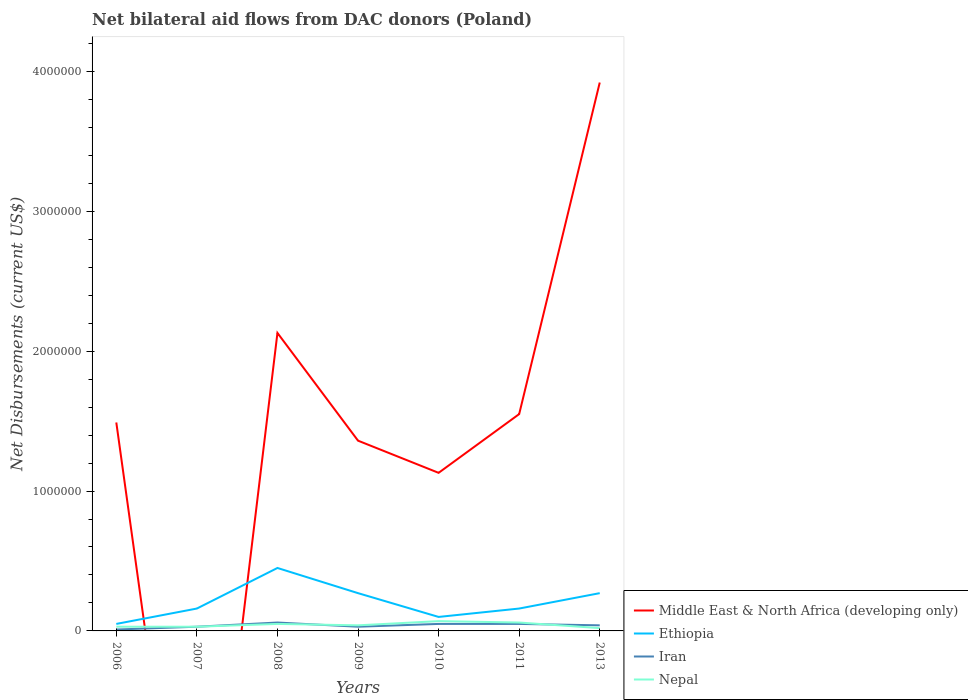Is the number of lines equal to the number of legend labels?
Offer a terse response. No. Across all years, what is the maximum net bilateral aid flows in Ethiopia?
Keep it short and to the point. 5.00e+04. What is the difference between the highest and the second highest net bilateral aid flows in Ethiopia?
Provide a short and direct response. 4.00e+05. What is the difference between the highest and the lowest net bilateral aid flows in Nepal?
Offer a very short reply. 3. Are the values on the major ticks of Y-axis written in scientific E-notation?
Make the answer very short. No. How many legend labels are there?
Offer a terse response. 4. How are the legend labels stacked?
Provide a succinct answer. Vertical. What is the title of the graph?
Ensure brevity in your answer.  Net bilateral aid flows from DAC donors (Poland). Does "Thailand" appear as one of the legend labels in the graph?
Make the answer very short. No. What is the label or title of the X-axis?
Keep it short and to the point. Years. What is the label or title of the Y-axis?
Ensure brevity in your answer.  Net Disbursements (current US$). What is the Net Disbursements (current US$) of Middle East & North Africa (developing only) in 2006?
Offer a terse response. 1.49e+06. What is the Net Disbursements (current US$) of Nepal in 2007?
Provide a succinct answer. 3.00e+04. What is the Net Disbursements (current US$) in Middle East & North Africa (developing only) in 2008?
Your response must be concise. 2.13e+06. What is the Net Disbursements (current US$) of Iran in 2008?
Provide a succinct answer. 6.00e+04. What is the Net Disbursements (current US$) of Middle East & North Africa (developing only) in 2009?
Make the answer very short. 1.36e+06. What is the Net Disbursements (current US$) of Ethiopia in 2009?
Your response must be concise. 2.70e+05. What is the Net Disbursements (current US$) in Iran in 2009?
Your answer should be compact. 3.00e+04. What is the Net Disbursements (current US$) of Middle East & North Africa (developing only) in 2010?
Provide a succinct answer. 1.13e+06. What is the Net Disbursements (current US$) in Ethiopia in 2010?
Ensure brevity in your answer.  1.00e+05. What is the Net Disbursements (current US$) of Nepal in 2010?
Your response must be concise. 7.00e+04. What is the Net Disbursements (current US$) in Middle East & North Africa (developing only) in 2011?
Give a very brief answer. 1.55e+06. What is the Net Disbursements (current US$) of Ethiopia in 2011?
Ensure brevity in your answer.  1.60e+05. What is the Net Disbursements (current US$) of Middle East & North Africa (developing only) in 2013?
Your response must be concise. 3.92e+06. What is the Net Disbursements (current US$) of Ethiopia in 2013?
Your answer should be compact. 2.70e+05. What is the Net Disbursements (current US$) of Iran in 2013?
Give a very brief answer. 4.00e+04. What is the Net Disbursements (current US$) in Nepal in 2013?
Offer a very short reply. 2.00e+04. Across all years, what is the maximum Net Disbursements (current US$) in Middle East & North Africa (developing only)?
Your response must be concise. 3.92e+06. Across all years, what is the maximum Net Disbursements (current US$) in Ethiopia?
Make the answer very short. 4.50e+05. Across all years, what is the maximum Net Disbursements (current US$) in Iran?
Provide a short and direct response. 6.00e+04. Across all years, what is the maximum Net Disbursements (current US$) in Nepal?
Offer a terse response. 7.00e+04. Across all years, what is the minimum Net Disbursements (current US$) in Nepal?
Your answer should be compact. 2.00e+04. What is the total Net Disbursements (current US$) of Middle East & North Africa (developing only) in the graph?
Provide a short and direct response. 1.16e+07. What is the total Net Disbursements (current US$) in Ethiopia in the graph?
Provide a short and direct response. 1.46e+06. What is the total Net Disbursements (current US$) in Iran in the graph?
Your answer should be very brief. 2.70e+05. What is the total Net Disbursements (current US$) of Nepal in the graph?
Your answer should be compact. 3.00e+05. What is the difference between the Net Disbursements (current US$) in Ethiopia in 2006 and that in 2007?
Keep it short and to the point. -1.10e+05. What is the difference between the Net Disbursements (current US$) in Iran in 2006 and that in 2007?
Your answer should be compact. -2.00e+04. What is the difference between the Net Disbursements (current US$) of Middle East & North Africa (developing only) in 2006 and that in 2008?
Offer a terse response. -6.40e+05. What is the difference between the Net Disbursements (current US$) of Ethiopia in 2006 and that in 2008?
Offer a terse response. -4.00e+05. What is the difference between the Net Disbursements (current US$) of Nepal in 2006 and that in 2008?
Give a very brief answer. -2.00e+04. What is the difference between the Net Disbursements (current US$) of Middle East & North Africa (developing only) in 2006 and that in 2009?
Offer a very short reply. 1.30e+05. What is the difference between the Net Disbursements (current US$) of Ethiopia in 2006 and that in 2009?
Provide a short and direct response. -2.20e+05. What is the difference between the Net Disbursements (current US$) of Iran in 2006 and that in 2009?
Keep it short and to the point. -2.00e+04. What is the difference between the Net Disbursements (current US$) of Nepal in 2006 and that in 2010?
Offer a very short reply. -4.00e+04. What is the difference between the Net Disbursements (current US$) in Middle East & North Africa (developing only) in 2006 and that in 2011?
Give a very brief answer. -6.00e+04. What is the difference between the Net Disbursements (current US$) in Ethiopia in 2006 and that in 2011?
Provide a short and direct response. -1.10e+05. What is the difference between the Net Disbursements (current US$) in Iran in 2006 and that in 2011?
Your response must be concise. -4.00e+04. What is the difference between the Net Disbursements (current US$) in Nepal in 2006 and that in 2011?
Keep it short and to the point. -3.00e+04. What is the difference between the Net Disbursements (current US$) in Middle East & North Africa (developing only) in 2006 and that in 2013?
Make the answer very short. -2.43e+06. What is the difference between the Net Disbursements (current US$) of Iran in 2006 and that in 2013?
Your answer should be compact. -3.00e+04. What is the difference between the Net Disbursements (current US$) of Nepal in 2006 and that in 2013?
Give a very brief answer. 10000. What is the difference between the Net Disbursements (current US$) in Nepal in 2007 and that in 2008?
Your answer should be very brief. -2.00e+04. What is the difference between the Net Disbursements (current US$) in Ethiopia in 2007 and that in 2009?
Make the answer very short. -1.10e+05. What is the difference between the Net Disbursements (current US$) in Iran in 2007 and that in 2009?
Offer a terse response. 0. What is the difference between the Net Disbursements (current US$) of Iran in 2007 and that in 2010?
Offer a terse response. -2.00e+04. What is the difference between the Net Disbursements (current US$) in Nepal in 2007 and that in 2010?
Keep it short and to the point. -4.00e+04. What is the difference between the Net Disbursements (current US$) in Ethiopia in 2007 and that in 2011?
Offer a very short reply. 0. What is the difference between the Net Disbursements (current US$) in Iran in 2007 and that in 2011?
Give a very brief answer. -2.00e+04. What is the difference between the Net Disbursements (current US$) in Ethiopia in 2007 and that in 2013?
Ensure brevity in your answer.  -1.10e+05. What is the difference between the Net Disbursements (current US$) in Middle East & North Africa (developing only) in 2008 and that in 2009?
Your answer should be compact. 7.70e+05. What is the difference between the Net Disbursements (current US$) of Ethiopia in 2008 and that in 2009?
Your answer should be very brief. 1.80e+05. What is the difference between the Net Disbursements (current US$) in Middle East & North Africa (developing only) in 2008 and that in 2010?
Provide a succinct answer. 1.00e+06. What is the difference between the Net Disbursements (current US$) of Ethiopia in 2008 and that in 2010?
Your response must be concise. 3.50e+05. What is the difference between the Net Disbursements (current US$) of Middle East & North Africa (developing only) in 2008 and that in 2011?
Keep it short and to the point. 5.80e+05. What is the difference between the Net Disbursements (current US$) of Ethiopia in 2008 and that in 2011?
Your answer should be compact. 2.90e+05. What is the difference between the Net Disbursements (current US$) in Nepal in 2008 and that in 2011?
Ensure brevity in your answer.  -10000. What is the difference between the Net Disbursements (current US$) in Middle East & North Africa (developing only) in 2008 and that in 2013?
Offer a terse response. -1.79e+06. What is the difference between the Net Disbursements (current US$) of Ethiopia in 2008 and that in 2013?
Provide a short and direct response. 1.80e+05. What is the difference between the Net Disbursements (current US$) in Iran in 2008 and that in 2013?
Make the answer very short. 2.00e+04. What is the difference between the Net Disbursements (current US$) of Nepal in 2009 and that in 2010?
Offer a very short reply. -3.00e+04. What is the difference between the Net Disbursements (current US$) in Iran in 2009 and that in 2011?
Offer a very short reply. -2.00e+04. What is the difference between the Net Disbursements (current US$) of Middle East & North Africa (developing only) in 2009 and that in 2013?
Make the answer very short. -2.56e+06. What is the difference between the Net Disbursements (current US$) in Iran in 2009 and that in 2013?
Provide a short and direct response. -10000. What is the difference between the Net Disbursements (current US$) of Nepal in 2009 and that in 2013?
Make the answer very short. 2.00e+04. What is the difference between the Net Disbursements (current US$) of Middle East & North Africa (developing only) in 2010 and that in 2011?
Your response must be concise. -4.20e+05. What is the difference between the Net Disbursements (current US$) in Ethiopia in 2010 and that in 2011?
Offer a terse response. -6.00e+04. What is the difference between the Net Disbursements (current US$) in Iran in 2010 and that in 2011?
Your answer should be very brief. 0. What is the difference between the Net Disbursements (current US$) in Nepal in 2010 and that in 2011?
Give a very brief answer. 10000. What is the difference between the Net Disbursements (current US$) of Middle East & North Africa (developing only) in 2010 and that in 2013?
Provide a short and direct response. -2.79e+06. What is the difference between the Net Disbursements (current US$) in Nepal in 2010 and that in 2013?
Your answer should be compact. 5.00e+04. What is the difference between the Net Disbursements (current US$) of Middle East & North Africa (developing only) in 2011 and that in 2013?
Make the answer very short. -2.37e+06. What is the difference between the Net Disbursements (current US$) in Ethiopia in 2011 and that in 2013?
Provide a succinct answer. -1.10e+05. What is the difference between the Net Disbursements (current US$) of Nepal in 2011 and that in 2013?
Offer a very short reply. 4.00e+04. What is the difference between the Net Disbursements (current US$) in Middle East & North Africa (developing only) in 2006 and the Net Disbursements (current US$) in Ethiopia in 2007?
Ensure brevity in your answer.  1.33e+06. What is the difference between the Net Disbursements (current US$) of Middle East & North Africa (developing only) in 2006 and the Net Disbursements (current US$) of Iran in 2007?
Keep it short and to the point. 1.46e+06. What is the difference between the Net Disbursements (current US$) in Middle East & North Africa (developing only) in 2006 and the Net Disbursements (current US$) in Nepal in 2007?
Give a very brief answer. 1.46e+06. What is the difference between the Net Disbursements (current US$) of Ethiopia in 2006 and the Net Disbursements (current US$) of Iran in 2007?
Your answer should be compact. 2.00e+04. What is the difference between the Net Disbursements (current US$) in Ethiopia in 2006 and the Net Disbursements (current US$) in Nepal in 2007?
Give a very brief answer. 2.00e+04. What is the difference between the Net Disbursements (current US$) of Iran in 2006 and the Net Disbursements (current US$) of Nepal in 2007?
Offer a very short reply. -2.00e+04. What is the difference between the Net Disbursements (current US$) of Middle East & North Africa (developing only) in 2006 and the Net Disbursements (current US$) of Ethiopia in 2008?
Provide a short and direct response. 1.04e+06. What is the difference between the Net Disbursements (current US$) of Middle East & North Africa (developing only) in 2006 and the Net Disbursements (current US$) of Iran in 2008?
Your answer should be compact. 1.43e+06. What is the difference between the Net Disbursements (current US$) of Middle East & North Africa (developing only) in 2006 and the Net Disbursements (current US$) of Nepal in 2008?
Ensure brevity in your answer.  1.44e+06. What is the difference between the Net Disbursements (current US$) in Ethiopia in 2006 and the Net Disbursements (current US$) in Nepal in 2008?
Your answer should be very brief. 0. What is the difference between the Net Disbursements (current US$) in Iran in 2006 and the Net Disbursements (current US$) in Nepal in 2008?
Your response must be concise. -4.00e+04. What is the difference between the Net Disbursements (current US$) in Middle East & North Africa (developing only) in 2006 and the Net Disbursements (current US$) in Ethiopia in 2009?
Provide a succinct answer. 1.22e+06. What is the difference between the Net Disbursements (current US$) of Middle East & North Africa (developing only) in 2006 and the Net Disbursements (current US$) of Iran in 2009?
Ensure brevity in your answer.  1.46e+06. What is the difference between the Net Disbursements (current US$) of Middle East & North Africa (developing only) in 2006 and the Net Disbursements (current US$) of Nepal in 2009?
Offer a terse response. 1.45e+06. What is the difference between the Net Disbursements (current US$) in Ethiopia in 2006 and the Net Disbursements (current US$) in Nepal in 2009?
Your answer should be compact. 10000. What is the difference between the Net Disbursements (current US$) in Middle East & North Africa (developing only) in 2006 and the Net Disbursements (current US$) in Ethiopia in 2010?
Provide a short and direct response. 1.39e+06. What is the difference between the Net Disbursements (current US$) in Middle East & North Africa (developing only) in 2006 and the Net Disbursements (current US$) in Iran in 2010?
Keep it short and to the point. 1.44e+06. What is the difference between the Net Disbursements (current US$) of Middle East & North Africa (developing only) in 2006 and the Net Disbursements (current US$) of Nepal in 2010?
Offer a terse response. 1.42e+06. What is the difference between the Net Disbursements (current US$) of Ethiopia in 2006 and the Net Disbursements (current US$) of Iran in 2010?
Provide a succinct answer. 0. What is the difference between the Net Disbursements (current US$) of Ethiopia in 2006 and the Net Disbursements (current US$) of Nepal in 2010?
Make the answer very short. -2.00e+04. What is the difference between the Net Disbursements (current US$) of Middle East & North Africa (developing only) in 2006 and the Net Disbursements (current US$) of Ethiopia in 2011?
Make the answer very short. 1.33e+06. What is the difference between the Net Disbursements (current US$) of Middle East & North Africa (developing only) in 2006 and the Net Disbursements (current US$) of Iran in 2011?
Keep it short and to the point. 1.44e+06. What is the difference between the Net Disbursements (current US$) in Middle East & North Africa (developing only) in 2006 and the Net Disbursements (current US$) in Nepal in 2011?
Offer a terse response. 1.43e+06. What is the difference between the Net Disbursements (current US$) of Ethiopia in 2006 and the Net Disbursements (current US$) of Nepal in 2011?
Provide a short and direct response. -10000. What is the difference between the Net Disbursements (current US$) in Middle East & North Africa (developing only) in 2006 and the Net Disbursements (current US$) in Ethiopia in 2013?
Offer a terse response. 1.22e+06. What is the difference between the Net Disbursements (current US$) of Middle East & North Africa (developing only) in 2006 and the Net Disbursements (current US$) of Iran in 2013?
Give a very brief answer. 1.45e+06. What is the difference between the Net Disbursements (current US$) in Middle East & North Africa (developing only) in 2006 and the Net Disbursements (current US$) in Nepal in 2013?
Give a very brief answer. 1.47e+06. What is the difference between the Net Disbursements (current US$) of Ethiopia in 2006 and the Net Disbursements (current US$) of Nepal in 2013?
Your answer should be compact. 3.00e+04. What is the difference between the Net Disbursements (current US$) of Ethiopia in 2007 and the Net Disbursements (current US$) of Iran in 2008?
Make the answer very short. 1.00e+05. What is the difference between the Net Disbursements (current US$) in Iran in 2007 and the Net Disbursements (current US$) in Nepal in 2008?
Your answer should be compact. -2.00e+04. What is the difference between the Net Disbursements (current US$) of Ethiopia in 2007 and the Net Disbursements (current US$) of Iran in 2009?
Give a very brief answer. 1.30e+05. What is the difference between the Net Disbursements (current US$) in Ethiopia in 2007 and the Net Disbursements (current US$) in Nepal in 2009?
Give a very brief answer. 1.20e+05. What is the difference between the Net Disbursements (current US$) in Ethiopia in 2007 and the Net Disbursements (current US$) in Iran in 2013?
Your response must be concise. 1.20e+05. What is the difference between the Net Disbursements (current US$) in Middle East & North Africa (developing only) in 2008 and the Net Disbursements (current US$) in Ethiopia in 2009?
Offer a very short reply. 1.86e+06. What is the difference between the Net Disbursements (current US$) of Middle East & North Africa (developing only) in 2008 and the Net Disbursements (current US$) of Iran in 2009?
Your response must be concise. 2.10e+06. What is the difference between the Net Disbursements (current US$) in Middle East & North Africa (developing only) in 2008 and the Net Disbursements (current US$) in Nepal in 2009?
Offer a very short reply. 2.09e+06. What is the difference between the Net Disbursements (current US$) in Iran in 2008 and the Net Disbursements (current US$) in Nepal in 2009?
Provide a succinct answer. 2.00e+04. What is the difference between the Net Disbursements (current US$) of Middle East & North Africa (developing only) in 2008 and the Net Disbursements (current US$) of Ethiopia in 2010?
Your response must be concise. 2.03e+06. What is the difference between the Net Disbursements (current US$) in Middle East & North Africa (developing only) in 2008 and the Net Disbursements (current US$) in Iran in 2010?
Your answer should be very brief. 2.08e+06. What is the difference between the Net Disbursements (current US$) of Middle East & North Africa (developing only) in 2008 and the Net Disbursements (current US$) of Nepal in 2010?
Ensure brevity in your answer.  2.06e+06. What is the difference between the Net Disbursements (current US$) of Iran in 2008 and the Net Disbursements (current US$) of Nepal in 2010?
Give a very brief answer. -10000. What is the difference between the Net Disbursements (current US$) of Middle East & North Africa (developing only) in 2008 and the Net Disbursements (current US$) of Ethiopia in 2011?
Provide a short and direct response. 1.97e+06. What is the difference between the Net Disbursements (current US$) of Middle East & North Africa (developing only) in 2008 and the Net Disbursements (current US$) of Iran in 2011?
Keep it short and to the point. 2.08e+06. What is the difference between the Net Disbursements (current US$) in Middle East & North Africa (developing only) in 2008 and the Net Disbursements (current US$) in Nepal in 2011?
Offer a terse response. 2.07e+06. What is the difference between the Net Disbursements (current US$) in Ethiopia in 2008 and the Net Disbursements (current US$) in Nepal in 2011?
Provide a succinct answer. 3.90e+05. What is the difference between the Net Disbursements (current US$) of Iran in 2008 and the Net Disbursements (current US$) of Nepal in 2011?
Offer a terse response. 0. What is the difference between the Net Disbursements (current US$) in Middle East & North Africa (developing only) in 2008 and the Net Disbursements (current US$) in Ethiopia in 2013?
Offer a terse response. 1.86e+06. What is the difference between the Net Disbursements (current US$) of Middle East & North Africa (developing only) in 2008 and the Net Disbursements (current US$) of Iran in 2013?
Offer a very short reply. 2.09e+06. What is the difference between the Net Disbursements (current US$) in Middle East & North Africa (developing only) in 2008 and the Net Disbursements (current US$) in Nepal in 2013?
Your answer should be compact. 2.11e+06. What is the difference between the Net Disbursements (current US$) in Iran in 2008 and the Net Disbursements (current US$) in Nepal in 2013?
Make the answer very short. 4.00e+04. What is the difference between the Net Disbursements (current US$) of Middle East & North Africa (developing only) in 2009 and the Net Disbursements (current US$) of Ethiopia in 2010?
Provide a short and direct response. 1.26e+06. What is the difference between the Net Disbursements (current US$) of Middle East & North Africa (developing only) in 2009 and the Net Disbursements (current US$) of Iran in 2010?
Give a very brief answer. 1.31e+06. What is the difference between the Net Disbursements (current US$) of Middle East & North Africa (developing only) in 2009 and the Net Disbursements (current US$) of Nepal in 2010?
Provide a succinct answer. 1.29e+06. What is the difference between the Net Disbursements (current US$) of Middle East & North Africa (developing only) in 2009 and the Net Disbursements (current US$) of Ethiopia in 2011?
Provide a short and direct response. 1.20e+06. What is the difference between the Net Disbursements (current US$) of Middle East & North Africa (developing only) in 2009 and the Net Disbursements (current US$) of Iran in 2011?
Offer a terse response. 1.31e+06. What is the difference between the Net Disbursements (current US$) in Middle East & North Africa (developing only) in 2009 and the Net Disbursements (current US$) in Nepal in 2011?
Your answer should be compact. 1.30e+06. What is the difference between the Net Disbursements (current US$) of Ethiopia in 2009 and the Net Disbursements (current US$) of Nepal in 2011?
Ensure brevity in your answer.  2.10e+05. What is the difference between the Net Disbursements (current US$) of Middle East & North Africa (developing only) in 2009 and the Net Disbursements (current US$) of Ethiopia in 2013?
Your answer should be compact. 1.09e+06. What is the difference between the Net Disbursements (current US$) in Middle East & North Africa (developing only) in 2009 and the Net Disbursements (current US$) in Iran in 2013?
Provide a succinct answer. 1.32e+06. What is the difference between the Net Disbursements (current US$) of Middle East & North Africa (developing only) in 2009 and the Net Disbursements (current US$) of Nepal in 2013?
Your response must be concise. 1.34e+06. What is the difference between the Net Disbursements (current US$) of Ethiopia in 2009 and the Net Disbursements (current US$) of Iran in 2013?
Offer a terse response. 2.30e+05. What is the difference between the Net Disbursements (current US$) in Ethiopia in 2009 and the Net Disbursements (current US$) in Nepal in 2013?
Give a very brief answer. 2.50e+05. What is the difference between the Net Disbursements (current US$) of Iran in 2009 and the Net Disbursements (current US$) of Nepal in 2013?
Make the answer very short. 10000. What is the difference between the Net Disbursements (current US$) in Middle East & North Africa (developing only) in 2010 and the Net Disbursements (current US$) in Ethiopia in 2011?
Ensure brevity in your answer.  9.70e+05. What is the difference between the Net Disbursements (current US$) of Middle East & North Africa (developing only) in 2010 and the Net Disbursements (current US$) of Iran in 2011?
Your response must be concise. 1.08e+06. What is the difference between the Net Disbursements (current US$) in Middle East & North Africa (developing only) in 2010 and the Net Disbursements (current US$) in Nepal in 2011?
Offer a very short reply. 1.07e+06. What is the difference between the Net Disbursements (current US$) in Ethiopia in 2010 and the Net Disbursements (current US$) in Iran in 2011?
Your response must be concise. 5.00e+04. What is the difference between the Net Disbursements (current US$) of Iran in 2010 and the Net Disbursements (current US$) of Nepal in 2011?
Offer a very short reply. -10000. What is the difference between the Net Disbursements (current US$) in Middle East & North Africa (developing only) in 2010 and the Net Disbursements (current US$) in Ethiopia in 2013?
Keep it short and to the point. 8.60e+05. What is the difference between the Net Disbursements (current US$) of Middle East & North Africa (developing only) in 2010 and the Net Disbursements (current US$) of Iran in 2013?
Keep it short and to the point. 1.09e+06. What is the difference between the Net Disbursements (current US$) of Middle East & North Africa (developing only) in 2010 and the Net Disbursements (current US$) of Nepal in 2013?
Make the answer very short. 1.11e+06. What is the difference between the Net Disbursements (current US$) of Ethiopia in 2010 and the Net Disbursements (current US$) of Iran in 2013?
Your answer should be very brief. 6.00e+04. What is the difference between the Net Disbursements (current US$) of Middle East & North Africa (developing only) in 2011 and the Net Disbursements (current US$) of Ethiopia in 2013?
Make the answer very short. 1.28e+06. What is the difference between the Net Disbursements (current US$) of Middle East & North Africa (developing only) in 2011 and the Net Disbursements (current US$) of Iran in 2013?
Ensure brevity in your answer.  1.51e+06. What is the difference between the Net Disbursements (current US$) of Middle East & North Africa (developing only) in 2011 and the Net Disbursements (current US$) of Nepal in 2013?
Your answer should be compact. 1.53e+06. What is the difference between the Net Disbursements (current US$) in Ethiopia in 2011 and the Net Disbursements (current US$) in Nepal in 2013?
Offer a terse response. 1.40e+05. What is the average Net Disbursements (current US$) of Middle East & North Africa (developing only) per year?
Ensure brevity in your answer.  1.65e+06. What is the average Net Disbursements (current US$) in Ethiopia per year?
Your answer should be compact. 2.09e+05. What is the average Net Disbursements (current US$) of Iran per year?
Offer a very short reply. 3.86e+04. What is the average Net Disbursements (current US$) in Nepal per year?
Ensure brevity in your answer.  4.29e+04. In the year 2006, what is the difference between the Net Disbursements (current US$) in Middle East & North Africa (developing only) and Net Disbursements (current US$) in Ethiopia?
Provide a short and direct response. 1.44e+06. In the year 2006, what is the difference between the Net Disbursements (current US$) in Middle East & North Africa (developing only) and Net Disbursements (current US$) in Iran?
Your response must be concise. 1.48e+06. In the year 2006, what is the difference between the Net Disbursements (current US$) of Middle East & North Africa (developing only) and Net Disbursements (current US$) of Nepal?
Keep it short and to the point. 1.46e+06. In the year 2006, what is the difference between the Net Disbursements (current US$) in Iran and Net Disbursements (current US$) in Nepal?
Your response must be concise. -2.00e+04. In the year 2007, what is the difference between the Net Disbursements (current US$) of Ethiopia and Net Disbursements (current US$) of Nepal?
Provide a short and direct response. 1.30e+05. In the year 2007, what is the difference between the Net Disbursements (current US$) of Iran and Net Disbursements (current US$) of Nepal?
Your response must be concise. 0. In the year 2008, what is the difference between the Net Disbursements (current US$) of Middle East & North Africa (developing only) and Net Disbursements (current US$) of Ethiopia?
Your response must be concise. 1.68e+06. In the year 2008, what is the difference between the Net Disbursements (current US$) of Middle East & North Africa (developing only) and Net Disbursements (current US$) of Iran?
Keep it short and to the point. 2.07e+06. In the year 2008, what is the difference between the Net Disbursements (current US$) in Middle East & North Africa (developing only) and Net Disbursements (current US$) in Nepal?
Keep it short and to the point. 2.08e+06. In the year 2008, what is the difference between the Net Disbursements (current US$) of Iran and Net Disbursements (current US$) of Nepal?
Ensure brevity in your answer.  10000. In the year 2009, what is the difference between the Net Disbursements (current US$) in Middle East & North Africa (developing only) and Net Disbursements (current US$) in Ethiopia?
Provide a succinct answer. 1.09e+06. In the year 2009, what is the difference between the Net Disbursements (current US$) in Middle East & North Africa (developing only) and Net Disbursements (current US$) in Iran?
Keep it short and to the point. 1.33e+06. In the year 2009, what is the difference between the Net Disbursements (current US$) of Middle East & North Africa (developing only) and Net Disbursements (current US$) of Nepal?
Offer a very short reply. 1.32e+06. In the year 2009, what is the difference between the Net Disbursements (current US$) in Ethiopia and Net Disbursements (current US$) in Nepal?
Your answer should be very brief. 2.30e+05. In the year 2009, what is the difference between the Net Disbursements (current US$) in Iran and Net Disbursements (current US$) in Nepal?
Give a very brief answer. -10000. In the year 2010, what is the difference between the Net Disbursements (current US$) of Middle East & North Africa (developing only) and Net Disbursements (current US$) of Ethiopia?
Give a very brief answer. 1.03e+06. In the year 2010, what is the difference between the Net Disbursements (current US$) in Middle East & North Africa (developing only) and Net Disbursements (current US$) in Iran?
Make the answer very short. 1.08e+06. In the year 2010, what is the difference between the Net Disbursements (current US$) in Middle East & North Africa (developing only) and Net Disbursements (current US$) in Nepal?
Offer a terse response. 1.06e+06. In the year 2010, what is the difference between the Net Disbursements (current US$) of Ethiopia and Net Disbursements (current US$) of Nepal?
Your answer should be compact. 3.00e+04. In the year 2010, what is the difference between the Net Disbursements (current US$) in Iran and Net Disbursements (current US$) in Nepal?
Your answer should be very brief. -2.00e+04. In the year 2011, what is the difference between the Net Disbursements (current US$) of Middle East & North Africa (developing only) and Net Disbursements (current US$) of Ethiopia?
Offer a very short reply. 1.39e+06. In the year 2011, what is the difference between the Net Disbursements (current US$) in Middle East & North Africa (developing only) and Net Disbursements (current US$) in Iran?
Provide a succinct answer. 1.50e+06. In the year 2011, what is the difference between the Net Disbursements (current US$) of Middle East & North Africa (developing only) and Net Disbursements (current US$) of Nepal?
Offer a very short reply. 1.49e+06. In the year 2011, what is the difference between the Net Disbursements (current US$) in Ethiopia and Net Disbursements (current US$) in Iran?
Offer a very short reply. 1.10e+05. In the year 2011, what is the difference between the Net Disbursements (current US$) in Iran and Net Disbursements (current US$) in Nepal?
Provide a succinct answer. -10000. In the year 2013, what is the difference between the Net Disbursements (current US$) in Middle East & North Africa (developing only) and Net Disbursements (current US$) in Ethiopia?
Make the answer very short. 3.65e+06. In the year 2013, what is the difference between the Net Disbursements (current US$) in Middle East & North Africa (developing only) and Net Disbursements (current US$) in Iran?
Offer a terse response. 3.88e+06. In the year 2013, what is the difference between the Net Disbursements (current US$) of Middle East & North Africa (developing only) and Net Disbursements (current US$) of Nepal?
Provide a short and direct response. 3.90e+06. In the year 2013, what is the difference between the Net Disbursements (current US$) in Ethiopia and Net Disbursements (current US$) in Iran?
Provide a succinct answer. 2.30e+05. What is the ratio of the Net Disbursements (current US$) of Ethiopia in 2006 to that in 2007?
Your answer should be very brief. 0.31. What is the ratio of the Net Disbursements (current US$) of Iran in 2006 to that in 2007?
Your answer should be compact. 0.33. What is the ratio of the Net Disbursements (current US$) in Middle East & North Africa (developing only) in 2006 to that in 2008?
Offer a terse response. 0.7. What is the ratio of the Net Disbursements (current US$) in Middle East & North Africa (developing only) in 2006 to that in 2009?
Ensure brevity in your answer.  1.1. What is the ratio of the Net Disbursements (current US$) of Ethiopia in 2006 to that in 2009?
Make the answer very short. 0.19. What is the ratio of the Net Disbursements (current US$) in Iran in 2006 to that in 2009?
Keep it short and to the point. 0.33. What is the ratio of the Net Disbursements (current US$) of Middle East & North Africa (developing only) in 2006 to that in 2010?
Keep it short and to the point. 1.32. What is the ratio of the Net Disbursements (current US$) of Ethiopia in 2006 to that in 2010?
Provide a short and direct response. 0.5. What is the ratio of the Net Disbursements (current US$) in Iran in 2006 to that in 2010?
Your answer should be compact. 0.2. What is the ratio of the Net Disbursements (current US$) in Nepal in 2006 to that in 2010?
Give a very brief answer. 0.43. What is the ratio of the Net Disbursements (current US$) in Middle East & North Africa (developing only) in 2006 to that in 2011?
Your answer should be very brief. 0.96. What is the ratio of the Net Disbursements (current US$) of Ethiopia in 2006 to that in 2011?
Give a very brief answer. 0.31. What is the ratio of the Net Disbursements (current US$) in Nepal in 2006 to that in 2011?
Your answer should be compact. 0.5. What is the ratio of the Net Disbursements (current US$) in Middle East & North Africa (developing only) in 2006 to that in 2013?
Offer a very short reply. 0.38. What is the ratio of the Net Disbursements (current US$) in Ethiopia in 2006 to that in 2013?
Ensure brevity in your answer.  0.19. What is the ratio of the Net Disbursements (current US$) of Iran in 2006 to that in 2013?
Your answer should be very brief. 0.25. What is the ratio of the Net Disbursements (current US$) in Ethiopia in 2007 to that in 2008?
Keep it short and to the point. 0.36. What is the ratio of the Net Disbursements (current US$) of Iran in 2007 to that in 2008?
Provide a succinct answer. 0.5. What is the ratio of the Net Disbursements (current US$) of Ethiopia in 2007 to that in 2009?
Keep it short and to the point. 0.59. What is the ratio of the Net Disbursements (current US$) in Iran in 2007 to that in 2009?
Your answer should be compact. 1. What is the ratio of the Net Disbursements (current US$) in Nepal in 2007 to that in 2009?
Keep it short and to the point. 0.75. What is the ratio of the Net Disbursements (current US$) in Nepal in 2007 to that in 2010?
Your response must be concise. 0.43. What is the ratio of the Net Disbursements (current US$) of Ethiopia in 2007 to that in 2011?
Give a very brief answer. 1. What is the ratio of the Net Disbursements (current US$) of Iran in 2007 to that in 2011?
Your response must be concise. 0.6. What is the ratio of the Net Disbursements (current US$) in Ethiopia in 2007 to that in 2013?
Make the answer very short. 0.59. What is the ratio of the Net Disbursements (current US$) in Iran in 2007 to that in 2013?
Provide a succinct answer. 0.75. What is the ratio of the Net Disbursements (current US$) of Middle East & North Africa (developing only) in 2008 to that in 2009?
Your response must be concise. 1.57. What is the ratio of the Net Disbursements (current US$) of Iran in 2008 to that in 2009?
Offer a very short reply. 2. What is the ratio of the Net Disbursements (current US$) of Middle East & North Africa (developing only) in 2008 to that in 2010?
Offer a very short reply. 1.89. What is the ratio of the Net Disbursements (current US$) of Ethiopia in 2008 to that in 2010?
Offer a very short reply. 4.5. What is the ratio of the Net Disbursements (current US$) of Middle East & North Africa (developing only) in 2008 to that in 2011?
Provide a short and direct response. 1.37. What is the ratio of the Net Disbursements (current US$) of Ethiopia in 2008 to that in 2011?
Provide a short and direct response. 2.81. What is the ratio of the Net Disbursements (current US$) of Nepal in 2008 to that in 2011?
Give a very brief answer. 0.83. What is the ratio of the Net Disbursements (current US$) of Middle East & North Africa (developing only) in 2008 to that in 2013?
Give a very brief answer. 0.54. What is the ratio of the Net Disbursements (current US$) of Ethiopia in 2008 to that in 2013?
Offer a terse response. 1.67. What is the ratio of the Net Disbursements (current US$) of Middle East & North Africa (developing only) in 2009 to that in 2010?
Make the answer very short. 1.2. What is the ratio of the Net Disbursements (current US$) in Nepal in 2009 to that in 2010?
Provide a succinct answer. 0.57. What is the ratio of the Net Disbursements (current US$) of Middle East & North Africa (developing only) in 2009 to that in 2011?
Provide a short and direct response. 0.88. What is the ratio of the Net Disbursements (current US$) in Ethiopia in 2009 to that in 2011?
Make the answer very short. 1.69. What is the ratio of the Net Disbursements (current US$) in Iran in 2009 to that in 2011?
Provide a short and direct response. 0.6. What is the ratio of the Net Disbursements (current US$) in Nepal in 2009 to that in 2011?
Make the answer very short. 0.67. What is the ratio of the Net Disbursements (current US$) of Middle East & North Africa (developing only) in 2009 to that in 2013?
Make the answer very short. 0.35. What is the ratio of the Net Disbursements (current US$) in Iran in 2009 to that in 2013?
Keep it short and to the point. 0.75. What is the ratio of the Net Disbursements (current US$) in Middle East & North Africa (developing only) in 2010 to that in 2011?
Give a very brief answer. 0.73. What is the ratio of the Net Disbursements (current US$) in Nepal in 2010 to that in 2011?
Provide a succinct answer. 1.17. What is the ratio of the Net Disbursements (current US$) in Middle East & North Africa (developing only) in 2010 to that in 2013?
Ensure brevity in your answer.  0.29. What is the ratio of the Net Disbursements (current US$) in Ethiopia in 2010 to that in 2013?
Your response must be concise. 0.37. What is the ratio of the Net Disbursements (current US$) in Iran in 2010 to that in 2013?
Provide a succinct answer. 1.25. What is the ratio of the Net Disbursements (current US$) in Nepal in 2010 to that in 2013?
Your answer should be very brief. 3.5. What is the ratio of the Net Disbursements (current US$) in Middle East & North Africa (developing only) in 2011 to that in 2013?
Your answer should be compact. 0.4. What is the ratio of the Net Disbursements (current US$) of Ethiopia in 2011 to that in 2013?
Make the answer very short. 0.59. What is the ratio of the Net Disbursements (current US$) in Iran in 2011 to that in 2013?
Provide a short and direct response. 1.25. What is the difference between the highest and the second highest Net Disbursements (current US$) of Middle East & North Africa (developing only)?
Offer a very short reply. 1.79e+06. What is the difference between the highest and the second highest Net Disbursements (current US$) in Ethiopia?
Your response must be concise. 1.80e+05. What is the difference between the highest and the second highest Net Disbursements (current US$) in Iran?
Give a very brief answer. 10000. What is the difference between the highest and the second highest Net Disbursements (current US$) in Nepal?
Your response must be concise. 10000. What is the difference between the highest and the lowest Net Disbursements (current US$) in Middle East & North Africa (developing only)?
Provide a short and direct response. 3.92e+06. 